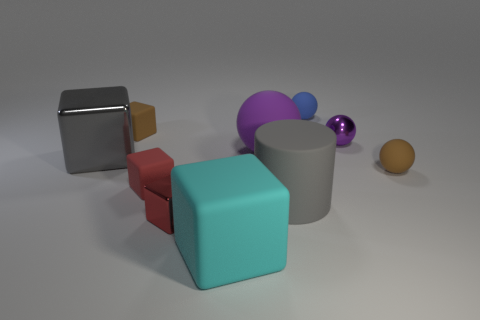Subtract 1 blocks. How many blocks are left? 4 Subtract all cyan cubes. How many cubes are left? 4 Subtract all gray cubes. How many cubes are left? 4 Subtract all cyan balls. Subtract all blue cylinders. How many balls are left? 4 Subtract all spheres. How many objects are left? 6 Add 7 tiny green metallic objects. How many tiny green metallic objects exist? 7 Subtract 0 green balls. How many objects are left? 10 Subtract all large purple objects. Subtract all big red matte things. How many objects are left? 9 Add 3 gray cubes. How many gray cubes are left? 4 